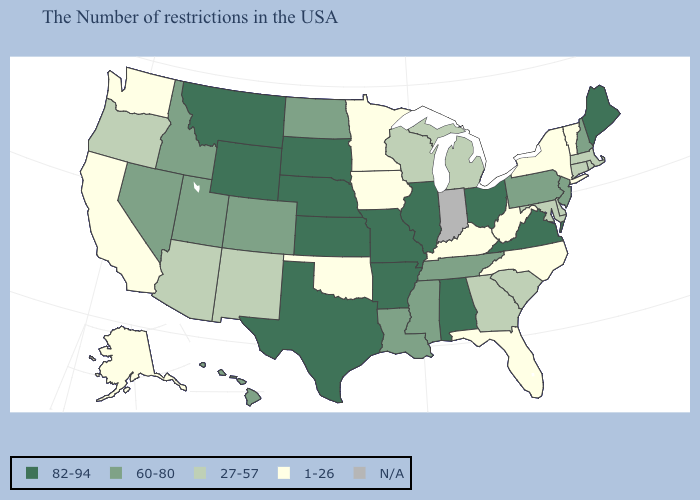What is the lowest value in the USA?
Short answer required. 1-26. What is the value of Alaska?
Quick response, please. 1-26. What is the highest value in states that border Missouri?
Quick response, please. 82-94. What is the value of Connecticut?
Write a very short answer. 27-57. Does the first symbol in the legend represent the smallest category?
Answer briefly. No. Name the states that have a value in the range 27-57?
Concise answer only. Massachusetts, Rhode Island, Connecticut, Delaware, Maryland, South Carolina, Georgia, Michigan, Wisconsin, New Mexico, Arizona, Oregon. What is the value of Montana?
Short answer required. 82-94. Which states have the highest value in the USA?
Answer briefly. Maine, Virginia, Ohio, Alabama, Illinois, Missouri, Arkansas, Kansas, Nebraska, Texas, South Dakota, Wyoming, Montana. What is the highest value in the Northeast ?
Answer briefly. 82-94. Does the map have missing data?
Answer briefly. Yes. Name the states that have a value in the range 1-26?
Keep it brief. Vermont, New York, North Carolina, West Virginia, Florida, Kentucky, Minnesota, Iowa, Oklahoma, California, Washington, Alaska. What is the value of Nevada?
Quick response, please. 60-80. Name the states that have a value in the range 60-80?
Answer briefly. New Hampshire, New Jersey, Pennsylvania, Tennessee, Mississippi, Louisiana, North Dakota, Colorado, Utah, Idaho, Nevada, Hawaii. 